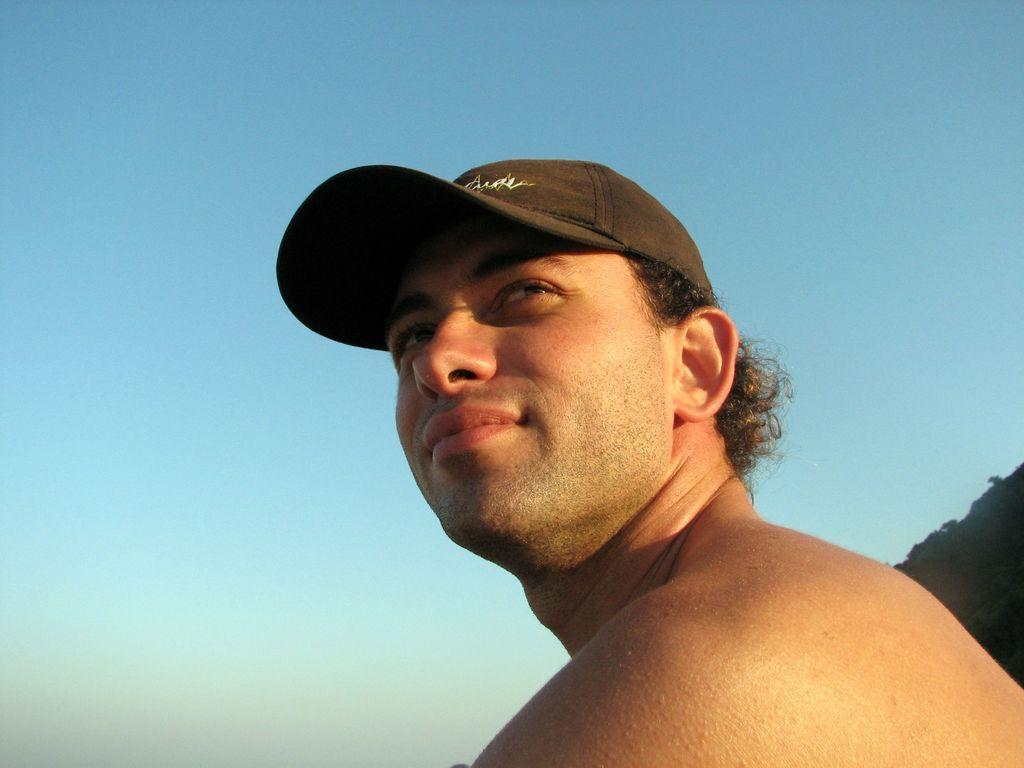How would you summarize this image in a sentence or two? In the front of the image I can see a person wore a cap. In the background there is a blue sky. 